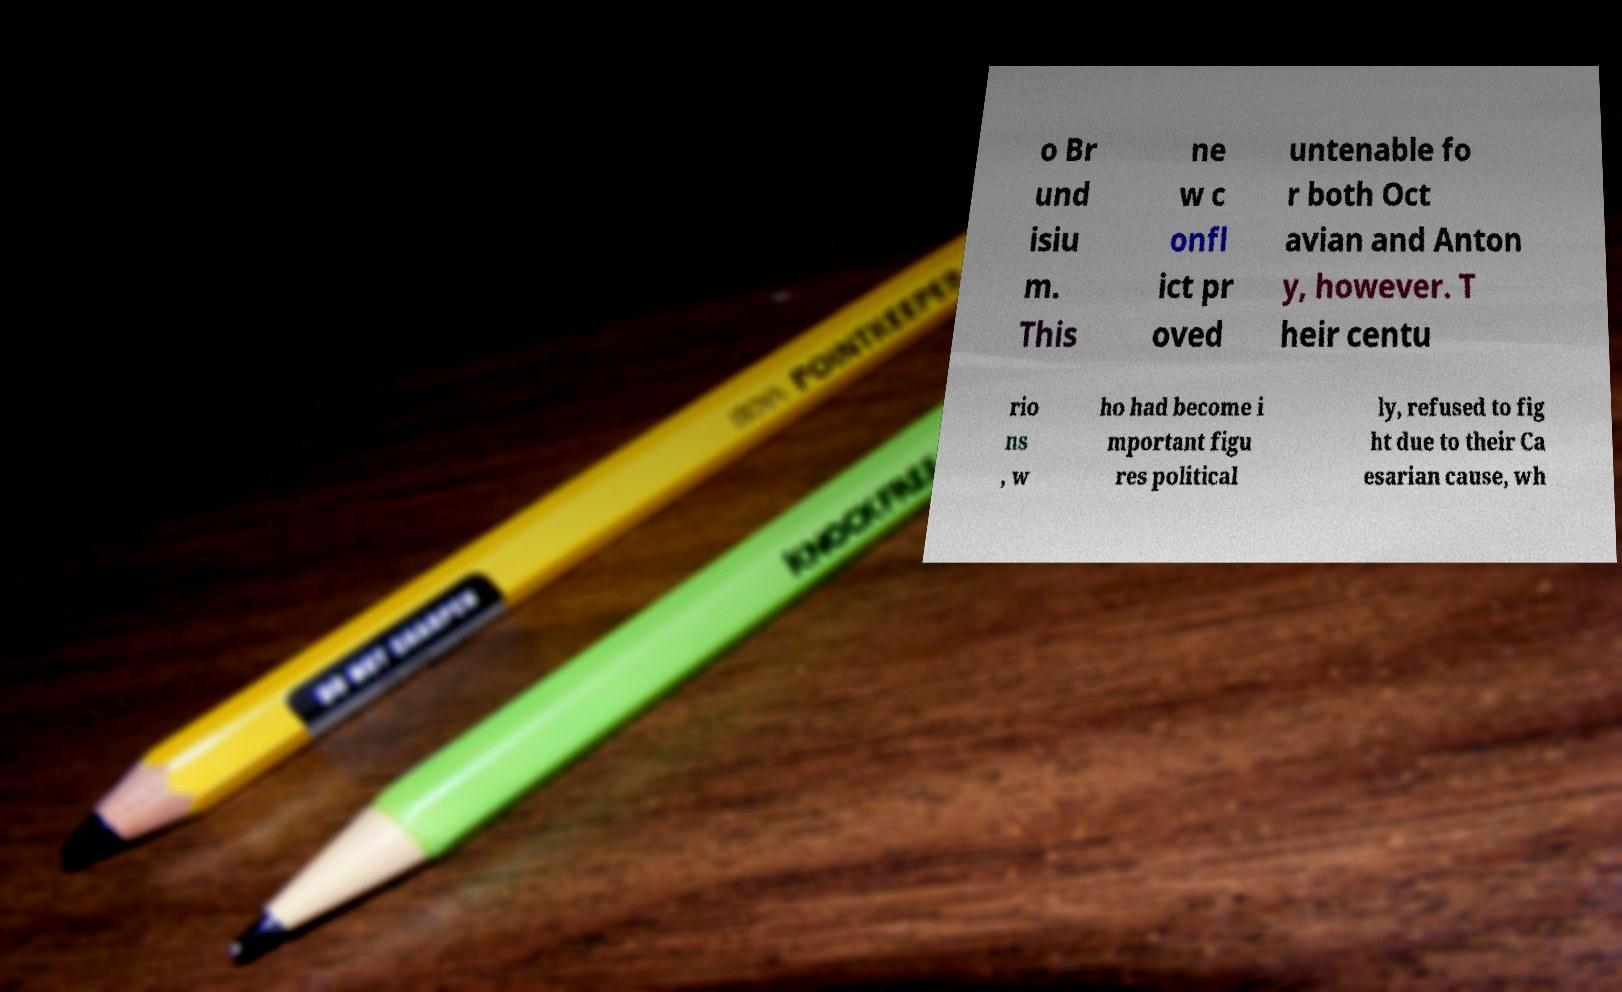Please identify and transcribe the text found in this image. o Br und isiu m. This ne w c onfl ict pr oved untenable fo r both Oct avian and Anton y, however. T heir centu rio ns , w ho had become i mportant figu res political ly, refused to fig ht due to their Ca esarian cause, wh 